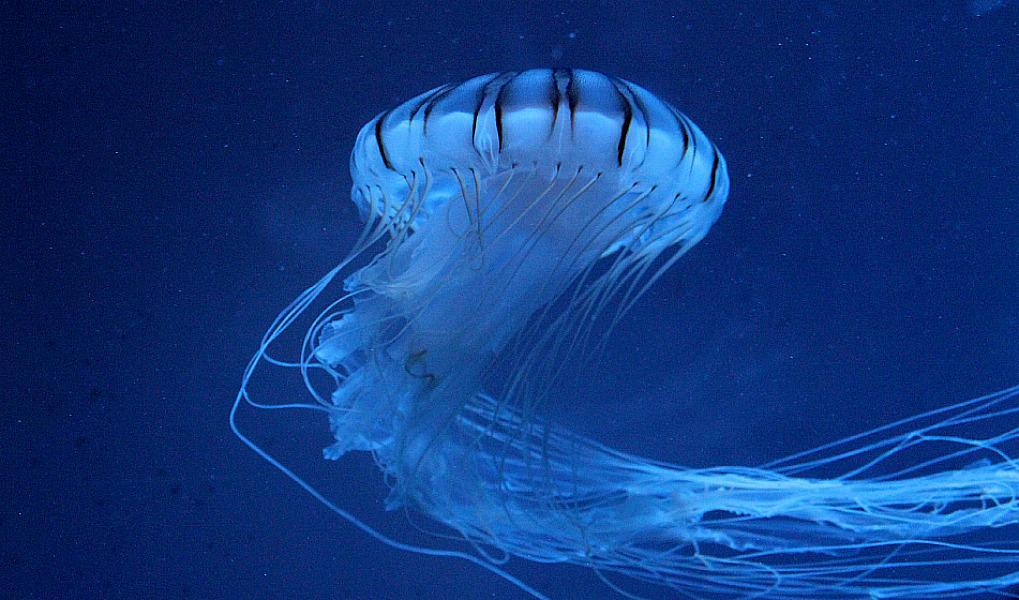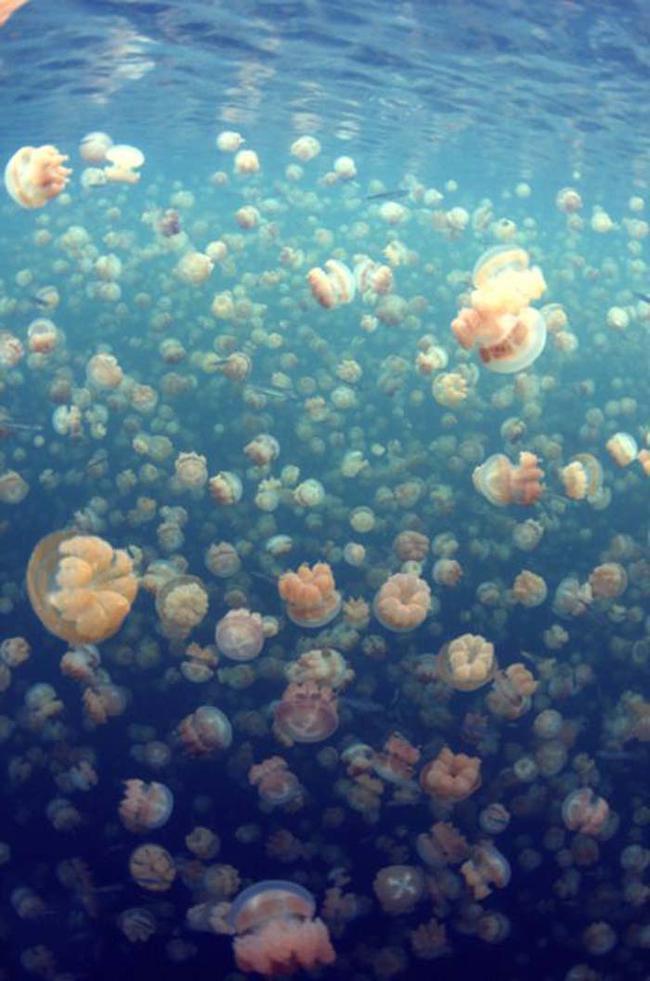The first image is the image on the left, the second image is the image on the right. Examine the images to the left and right. Is the description "There is a single jellyfish in the image on the left" accurate? Answer yes or no. Yes. The first image is the image on the left, the second image is the image on the right. Evaluate the accuracy of this statement regarding the images: "Left image shows a prominent jellyfish in foreground with many smaller jellyfish in the background.". Is it true? Answer yes or no. No. 